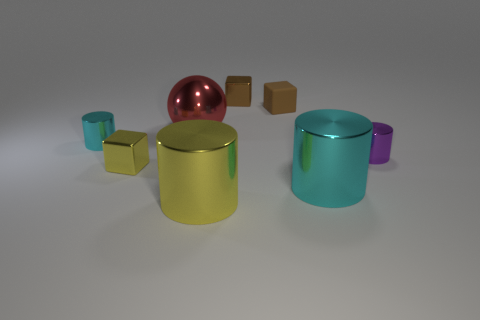Are there any patterns or inscriptions on any of the objects? From the current perspective, we do not see any intricate patterns or inscriptions on the objects. They appear to have solid colors with a focus on simplicity and geometrical shapes. The lighting and shadows cast allow for a clear view, yet no additional details in the form of text or patterns are visible on their surfaces. 